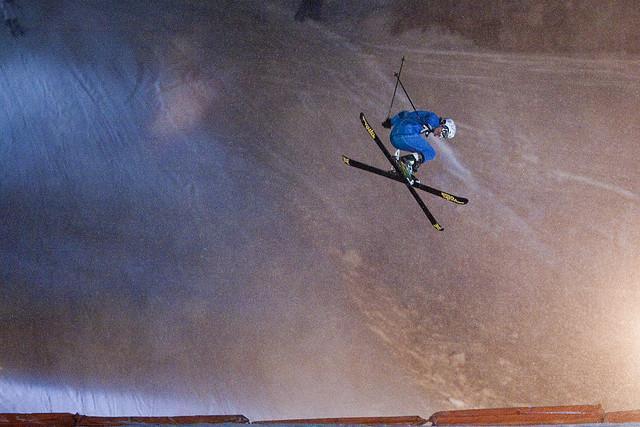How many beds in this image require a ladder to get into?
Give a very brief answer. 0. 